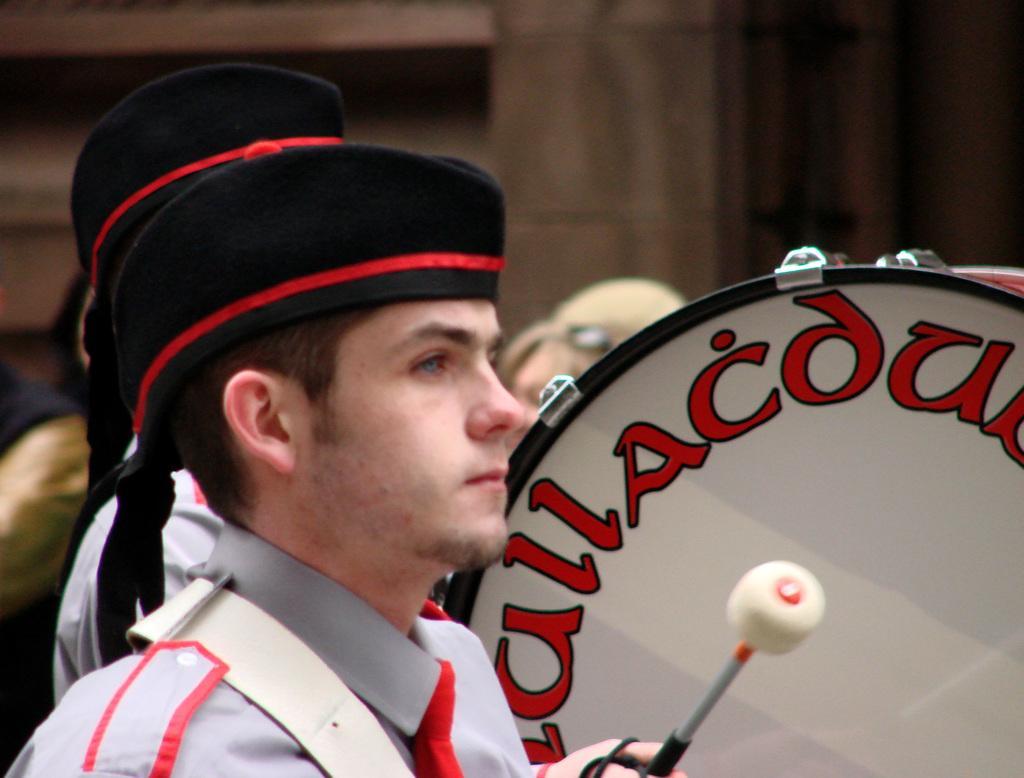Describe this image in one or two sentences. In this image, on the left side, we can see a man wearing a black color hat. On the left side, we can also see a another man wearing a black color hat and having a stick in his hand. On the right side, we can see a musical instrument. In the background, we can see a group of people and a wall. 